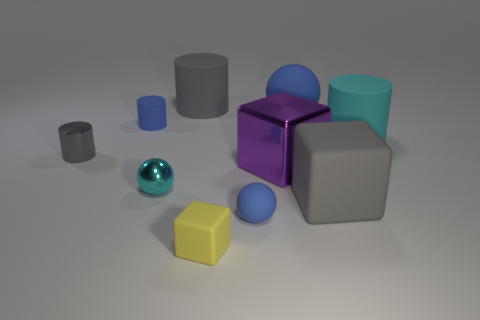What material is the other cylinder that is the same color as the metal cylinder?
Your answer should be very brief. Rubber. The yellow block is what size?
Ensure brevity in your answer.  Small. What material is the purple object that is the same size as the cyan cylinder?
Ensure brevity in your answer.  Metal. What color is the tiny matte cylinder that is on the right side of the tiny gray metallic object?
Ensure brevity in your answer.  Blue. How many big brown rubber balls are there?
Your answer should be compact. 0. Are there any big purple blocks left of the cyan object that is in front of the cyan cylinder that is behind the small blue rubber ball?
Ensure brevity in your answer.  No. What shape is the metal object that is the same size as the shiny ball?
Your answer should be compact. Cylinder. What number of other objects are the same color as the tiny matte cylinder?
Your response must be concise. 2. What is the material of the yellow block?
Offer a terse response. Rubber. What number of other objects are there of the same material as the tiny cube?
Keep it short and to the point. 6. 